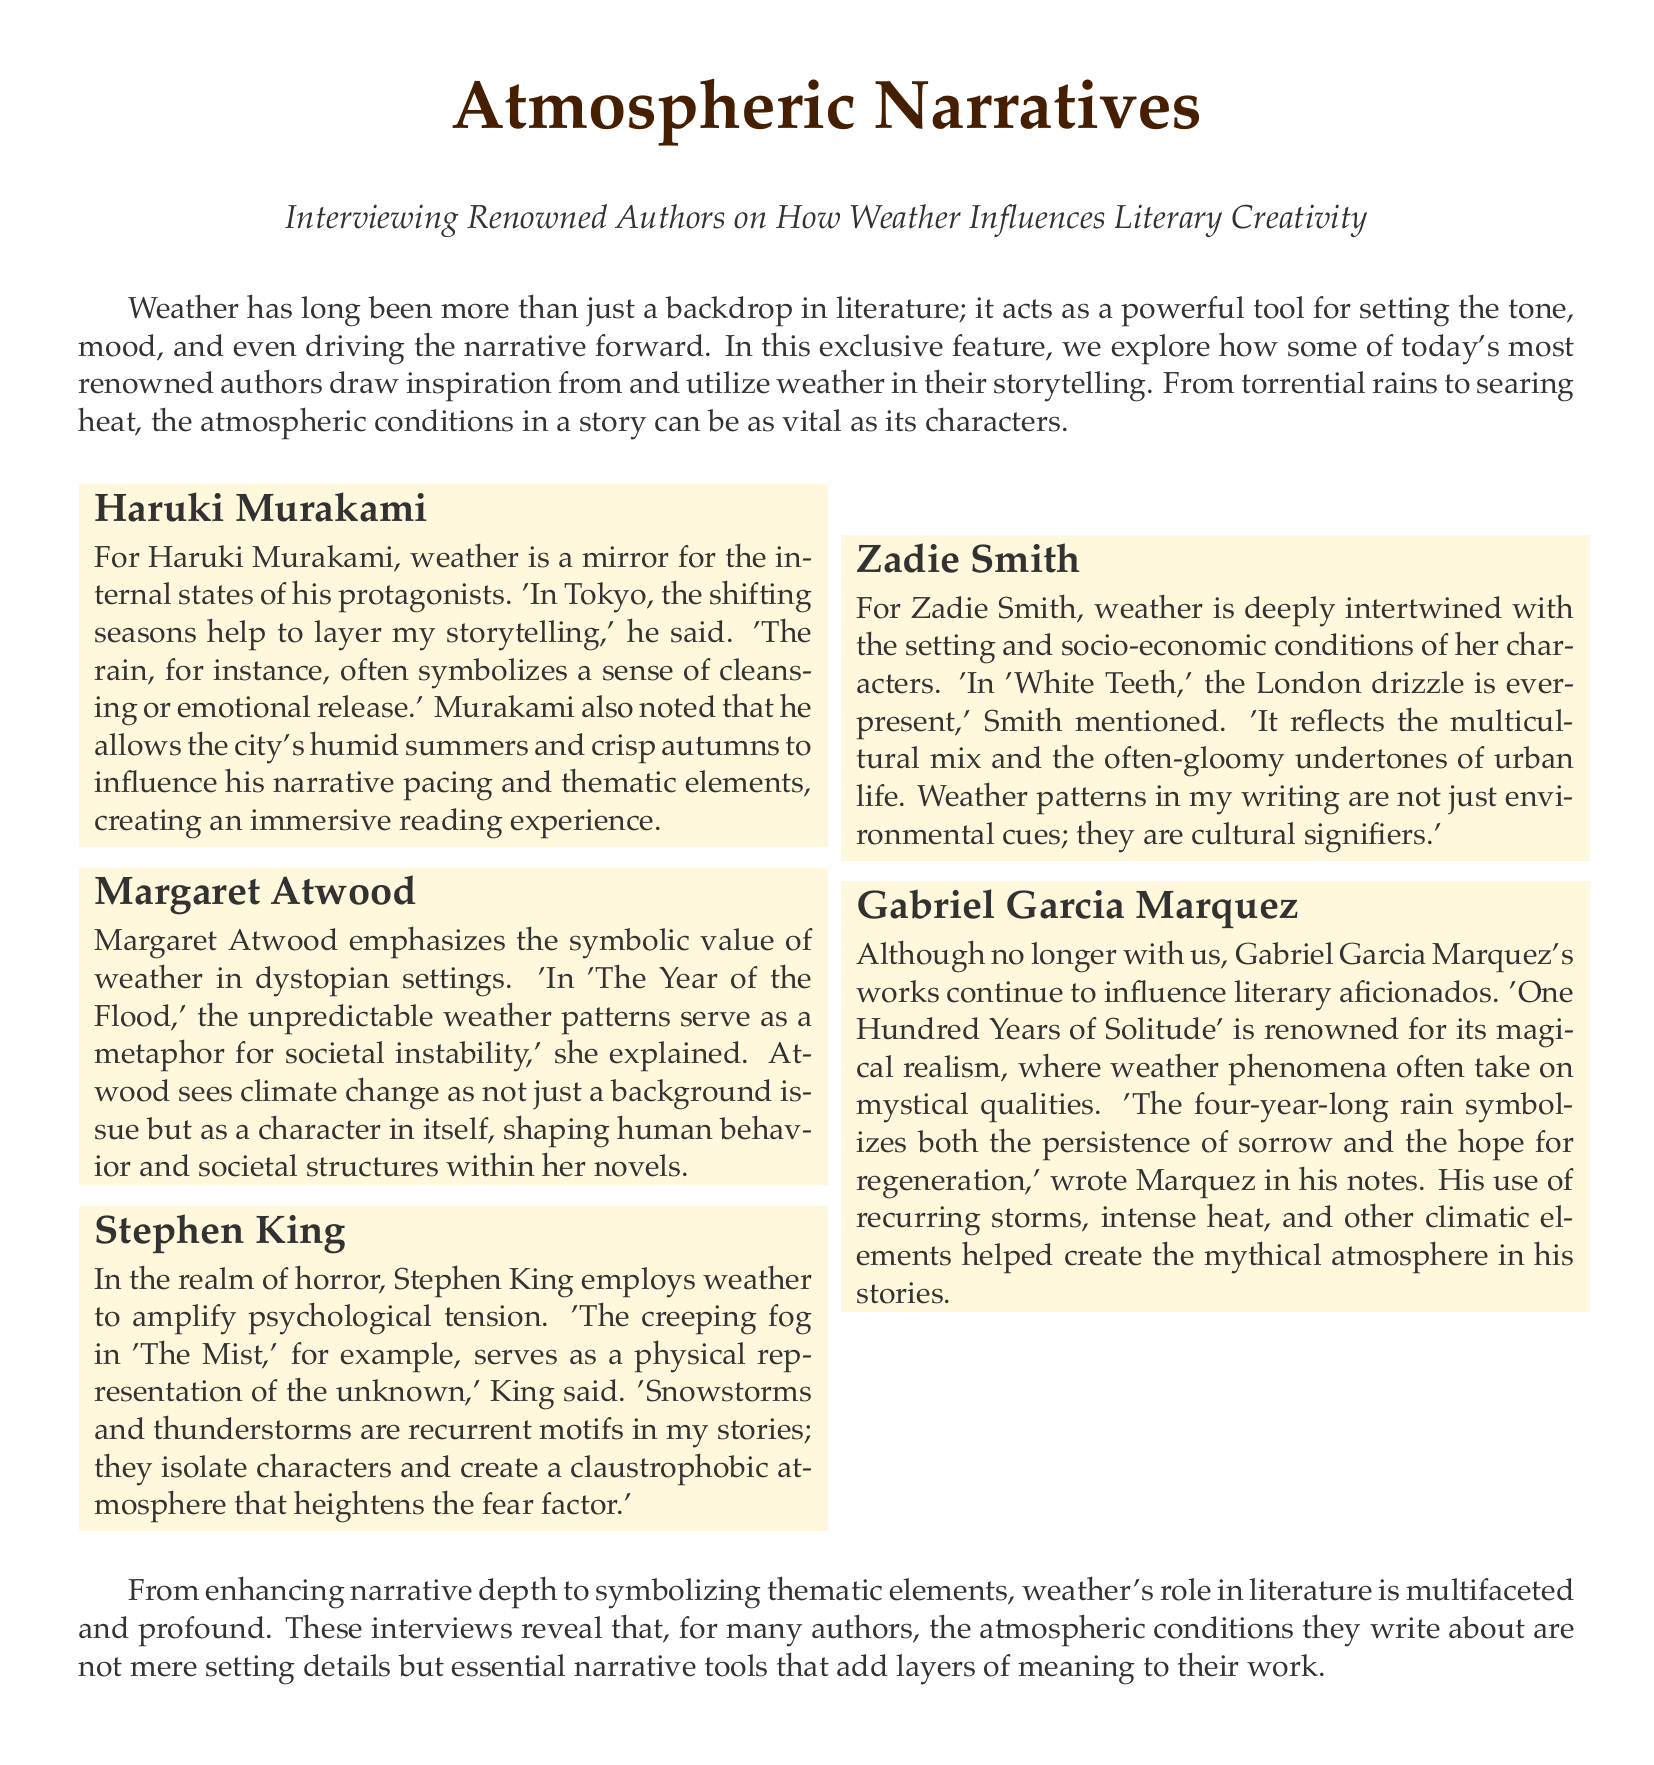What does weather symbolize in Haruki Murakami's works? Haruki Murakami states that the rain often symbolizes a sense of cleansing or emotional release.
Answer: cleansing or emotional release What role does weather play in Margaret Atwood's 'The Year of the Flood'? Margaret Atwood mentions that unpredictable weather patterns serve as a metaphor for societal instability.
Answer: societal instability Which author uses fog as a representation of the unknown? Stephen King employs weather, particularly fog, as a physical representation of the unknown in 'The Mist.'
Answer: Stephen King How does Zadie Smith describe the impact of London drizzle in 'White Teeth'? Zadie Smith describes the London drizzle as reflecting the multicultural mix and the often-gloomy undertones of urban life.
Answer: multicultural mix and gloom What notable weather phenomenon is referenced in Gabriel Garcia Marquez's 'One Hundred Years of Solitude'? In 'One Hundred Years of Solitude,' a four-year-long rain symbolizes both the persistence of sorrow and the hope for regeneration.
Answer: four-year-long rain How does Stephen King use weather to create atmosphere? Stephen King uses snowstorms and thunderstorms as recurrent motifs to create a claustrophobic atmosphere that heightens fear.
Answer: claustrophobic atmosphere What is the document type of this feature? This document is a weather report on how weather influences literary creativity.
Answer: weather report How many renowned authors are interviewed in this feature? The feature includes interviews with five renowned authors.
Answer: five 